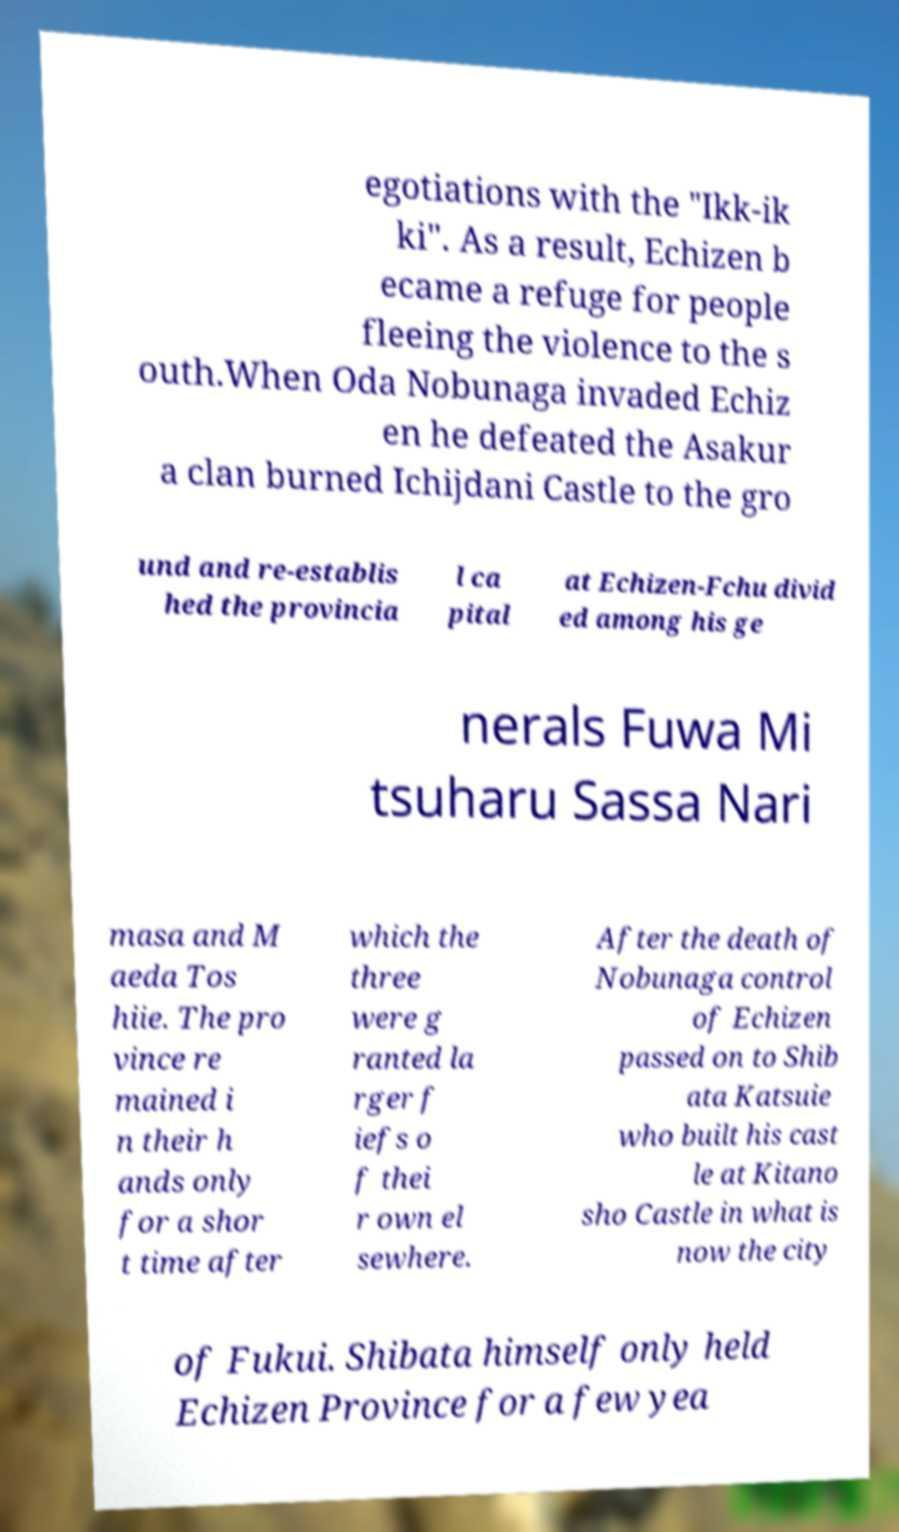For documentation purposes, I need the text within this image transcribed. Could you provide that? egotiations with the "Ikk-ik ki". As a result, Echizen b ecame a refuge for people fleeing the violence to the s outh.When Oda Nobunaga invaded Echiz en he defeated the Asakur a clan burned Ichijdani Castle to the gro und and re-establis hed the provincia l ca pital at Echizen-Fchu divid ed among his ge nerals Fuwa Mi tsuharu Sassa Nari masa and M aeda Tos hiie. The pro vince re mained i n their h ands only for a shor t time after which the three were g ranted la rger f iefs o f thei r own el sewhere. After the death of Nobunaga control of Echizen passed on to Shib ata Katsuie who built his cast le at Kitano sho Castle in what is now the city of Fukui. Shibata himself only held Echizen Province for a few yea 